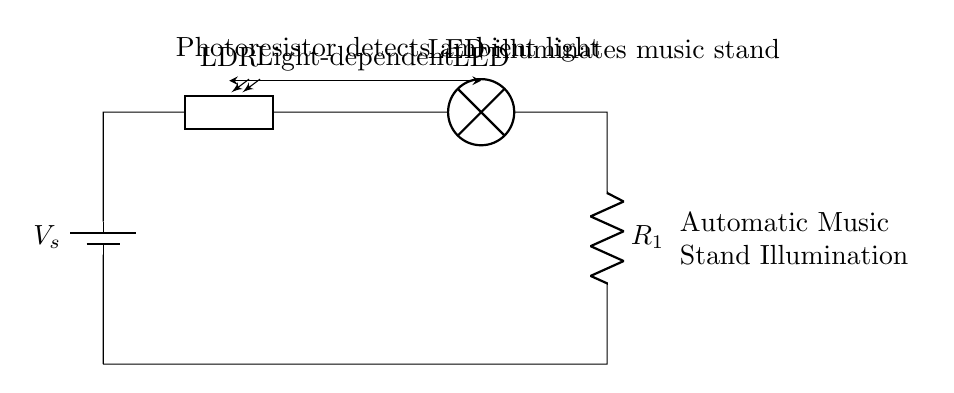What type of circuit is this? This circuit is a series circuit as all components are connected end-to-end along a single path. This can be seen from how the battery, photoresistor, LED, and resistor are connected sequentially.
Answer: series circuit What component detects ambient light? The component that detects ambient light is the photoresistor. It is specifically labeled as LDR in the circuit diagram, indicating its role in sensing light levels.
Answer: photoresistor What illuminates the music stand? The LED illuminates the music stand, as indicated by its label in the circuit diagram, where it is connected in series with the other components.
Answer: LED What is the role of the resistor in this circuit? The resistor limits the current flowing through the circuit, which helps protect the LED from excessive current that could cause damage. Its function is critical for the safe operation of the LED when it’s powered on.
Answer: limit current How does the photoresistor affect LED operation? The photoresistor affects the LED operation by varying its resistance based on light levels. In low light, the resistance is high, allowing more current to flow to the LED. Conversely, in bright light, it has low resistance, reducing the LED's brightness or turning it off.
Answer: varies resistance What happens to the current when it’s dark? When it’s dark, the photoresistor’s resistance increases, which allows more current to flow through the circuit, causing the LED to illuminate the music stand. This is because the higher resistance means less diversion of current away from the LED.
Answer: current increases 